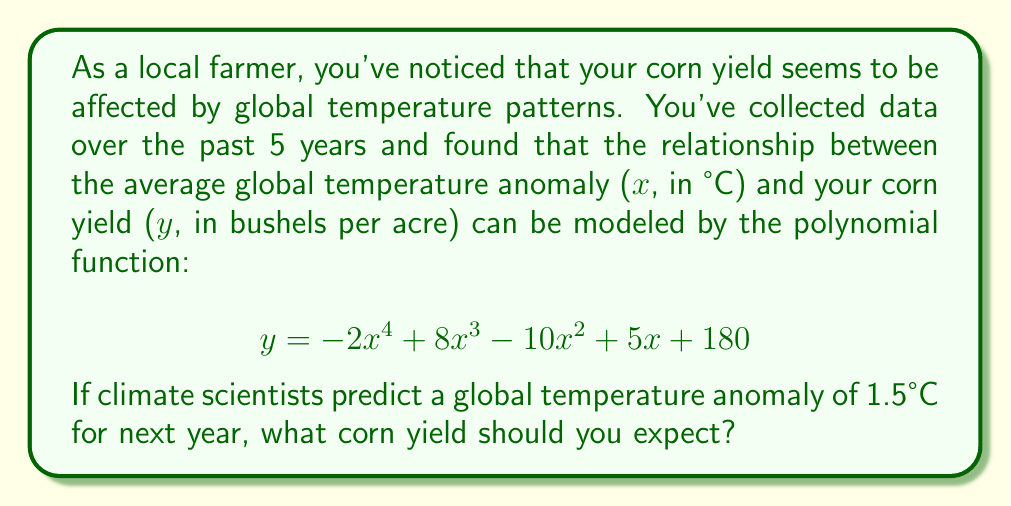Can you answer this question? To solve this problem, we need to evaluate the given polynomial function at x = 1.5°C. Let's break it down step-by-step:

1) The polynomial function is:
   $$y = -2x^4 + 8x^3 - 10x^2 + 5x + 180$$

2) We need to substitute x = 1.5 into this equation:
   $$y = -2(1.5)^4 + 8(1.5)^3 - 10(1.5)^2 + 5(1.5) + 180$$

3) Let's evaluate each term:
   a) $-2(1.5)^4 = -2(5.0625) = -10.125$
   b) $8(1.5)^3 = 8(3.375) = 27$
   c) $-10(1.5)^2 = -10(2.25) = -22.5$
   d) $5(1.5) = 7.5$
   e) The constant term is 180

4) Now, let's sum up all these terms:
   $$y = -10.125 + 27 - 22.5 + 7.5 + 180 = 181.875$$

5) Rounding to the nearest whole number (as crop yields are typically reported in whole bushels):
   $$y ≈ 182$$

Therefore, with a global temperature anomaly of 1.5°C, you should expect a corn yield of approximately 182 bushels per acre.
Answer: 182 bushels per acre 